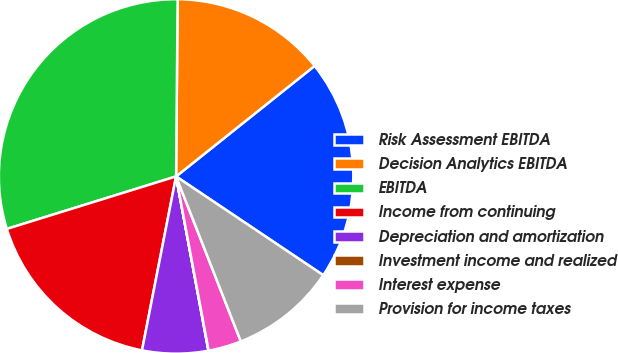Convert chart. <chart><loc_0><loc_0><loc_500><loc_500><pie_chart><fcel>Risk Assessment EBITDA<fcel>Decision Analytics EBITDA<fcel>EBITDA<fcel>Income from continuing<fcel>Depreciation and amortization<fcel>Investment income and realized<fcel>Interest expense<fcel>Provision for income taxes<nl><fcel>20.12%<fcel>14.14%<fcel>29.92%<fcel>17.13%<fcel>6.0%<fcel>0.02%<fcel>3.01%<fcel>9.64%<nl></chart> 